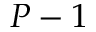Convert formula to latex. <formula><loc_0><loc_0><loc_500><loc_500>P - 1</formula> 